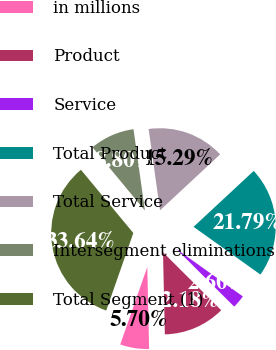Convert chart. <chart><loc_0><loc_0><loc_500><loc_500><pie_chart><fcel>in millions<fcel>Product<fcel>Service<fcel>Total Product<fcel>Total Service<fcel>Intersegment eliminations<fcel>Total Segment (1)<nl><fcel>5.7%<fcel>12.18%<fcel>2.6%<fcel>21.79%<fcel>15.29%<fcel>8.8%<fcel>33.64%<nl></chart> 